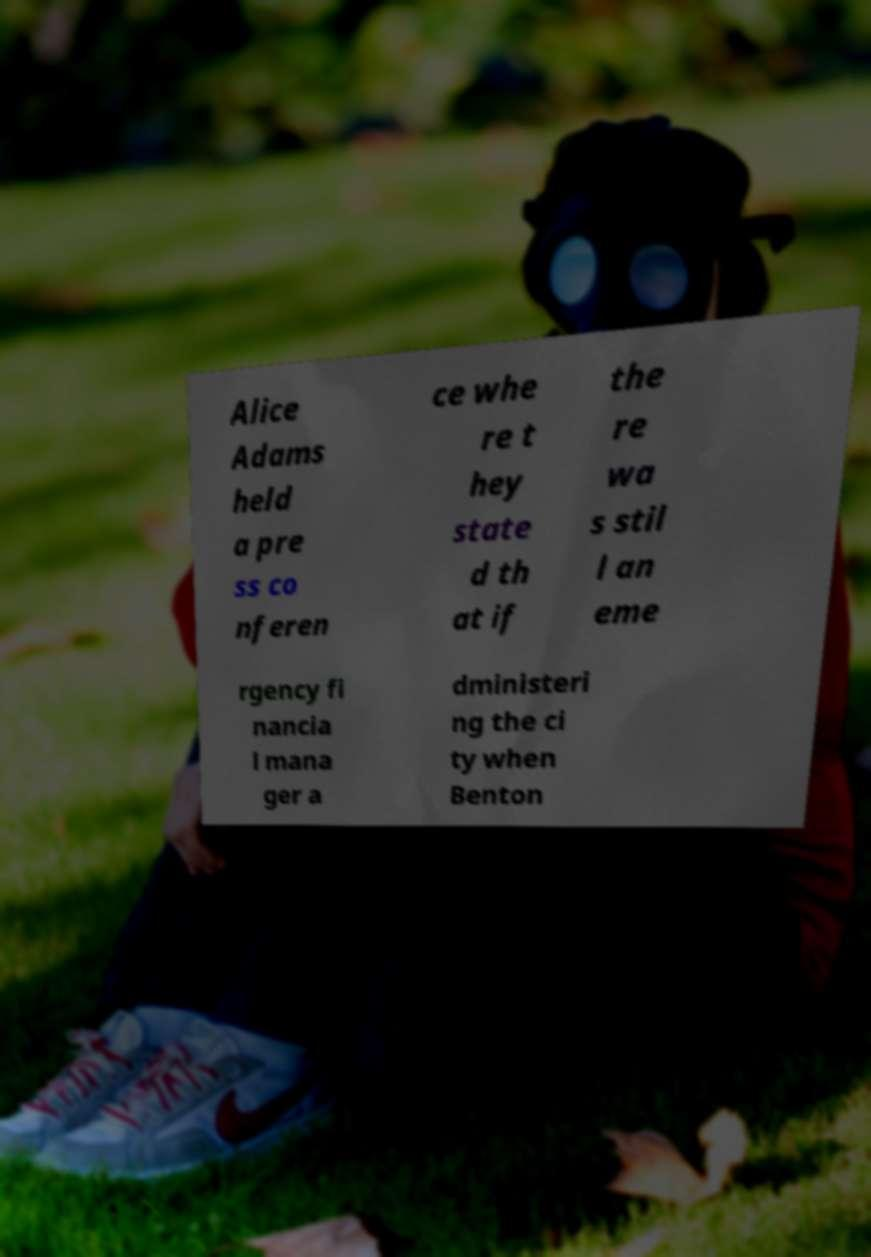Please identify and transcribe the text found in this image. Alice Adams held a pre ss co nferen ce whe re t hey state d th at if the re wa s stil l an eme rgency fi nancia l mana ger a dministeri ng the ci ty when Benton 